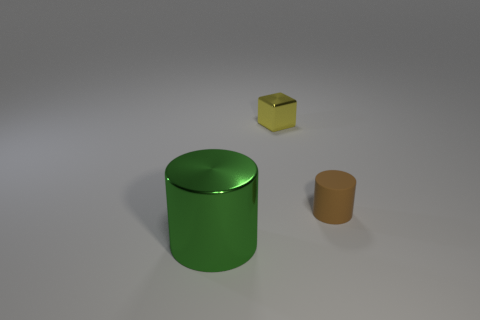Is the size of the metal cylinder the same as the brown matte object?
Ensure brevity in your answer.  No. What material is the brown object that is the same shape as the big green metallic object?
Your answer should be compact. Rubber. Is there anything else that is the same material as the large thing?
Provide a short and direct response. Yes. How many cyan objects are either small metal things or tiny rubber cylinders?
Provide a short and direct response. 0. There is a cylinder in front of the tiny brown rubber cylinder; what is it made of?
Provide a succinct answer. Metal. Is the number of big things greater than the number of purple shiny objects?
Keep it short and to the point. Yes. Is the shape of the metal object that is behind the large green metallic cylinder the same as  the brown thing?
Make the answer very short. No. How many metal things are both behind the large metal cylinder and in front of the tiny metal block?
Your response must be concise. 0. What number of gray metal objects are the same shape as the matte object?
Offer a terse response. 0. What color is the metallic thing right of the thing in front of the tiny brown thing?
Offer a very short reply. Yellow. 